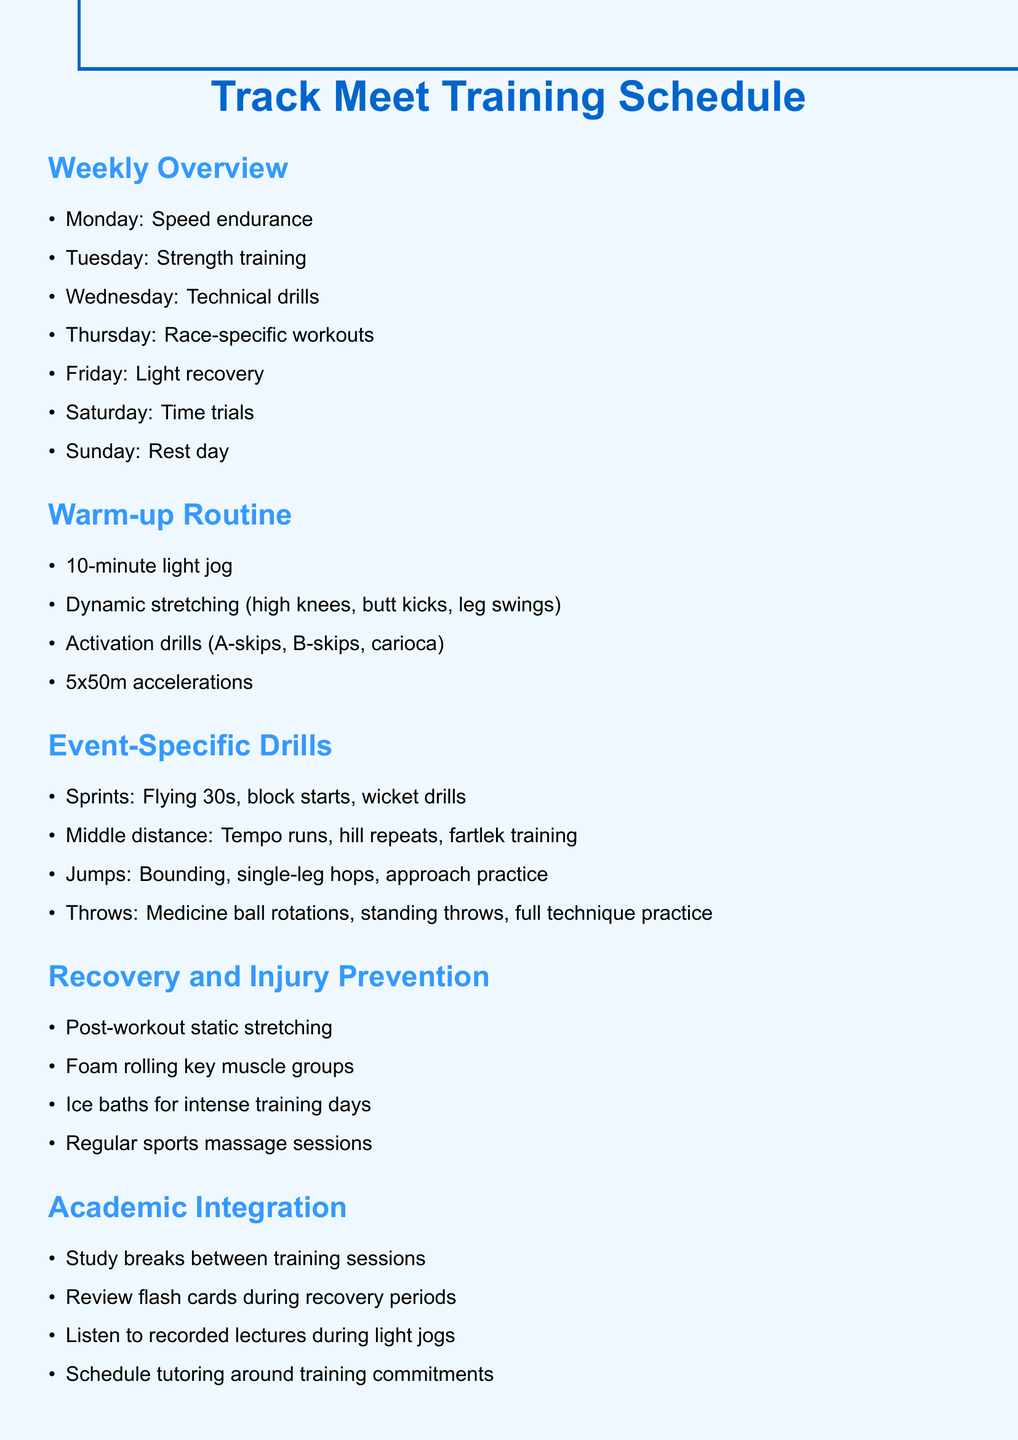What is the focus of Monday's training? The focus of Monday's training is specified as speed endurance in the weekly overview.
Answer: Speed endurance How many dynamic stretching exercises are listed? The warm-up routine lists three types of dynamic stretching exercises, specifically high knees, butt kicks, and leg swings.
Answer: Three What is the first exercise in the warm-up routine? The first exercise in the warm-up routine is a 10-minute light jog.
Answer: 10-minute light jog Which day is designated as the rest day? According to the weekly overview, Sunday is specifically designated as the rest day.
Answer: Sunday What specific drill is included for sprints? The event-specific drills for sprints include flying 30s, block starts, and wicket drills; one specific drill is flying 30s.
Answer: Flying 30s What type of recovery method is suggested after intense training days? The document suggests ice baths as a recovery method after intense training days.
Answer: Ice baths Which day features time trials? Saturday is the day that features time trials according to the weekly overview.
Answer: Saturday What should be done during study breaks? The document suggests taking short breaks for study between training sessions, specifying they are for reviewing flash cards.
Answer: Reviewing flash cards What is the last section of the document? The last section of the document is dedicated to academic integration, highlighting how to balance studies and training.
Answer: Academic Integration 